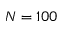Convert formula to latex. <formula><loc_0><loc_0><loc_500><loc_500>N = 1 0 0</formula> 